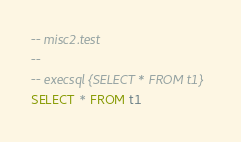<code> <loc_0><loc_0><loc_500><loc_500><_SQL_>-- misc2.test
-- 
-- execsql {SELECT * FROM t1}
SELECT * FROM t1</code> 